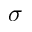Convert formula to latex. <formula><loc_0><loc_0><loc_500><loc_500>\sigma</formula> 